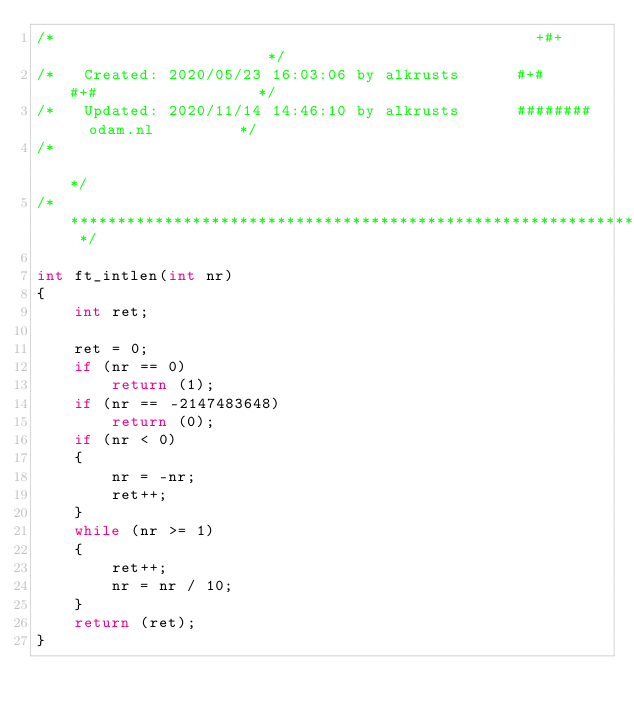<code> <loc_0><loc_0><loc_500><loc_500><_C_>/*                                                   +#+                      */
/*   Created: 2020/05/23 16:03:06 by alkrusts      #+#    #+#                 */
/*   Updated: 2020/11/14 14:46:10 by alkrusts      ########   odam.nl         */
/*                                                                            */
/* ************************************************************************** */

int	ft_intlen(int nr)
{
	int	ret;

	ret = 0;
	if (nr == 0)
		return (1);
	if (nr == -2147483648)
		return (0);
	if (nr < 0)
	{
		nr = -nr;
		ret++;
	}
	while (nr >= 1)
	{
		ret++;
		nr = nr / 10;
	}
	return (ret);
}
</code> 